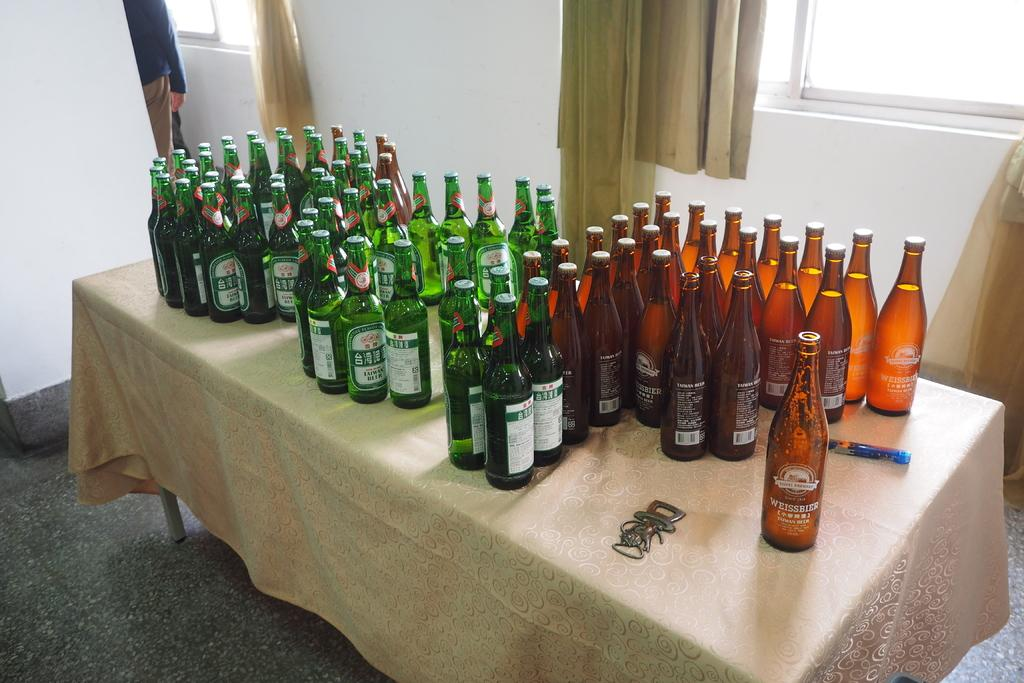<image>
Describe the image concisely. Many green and brown beer bottles on a table, including Weissibier 